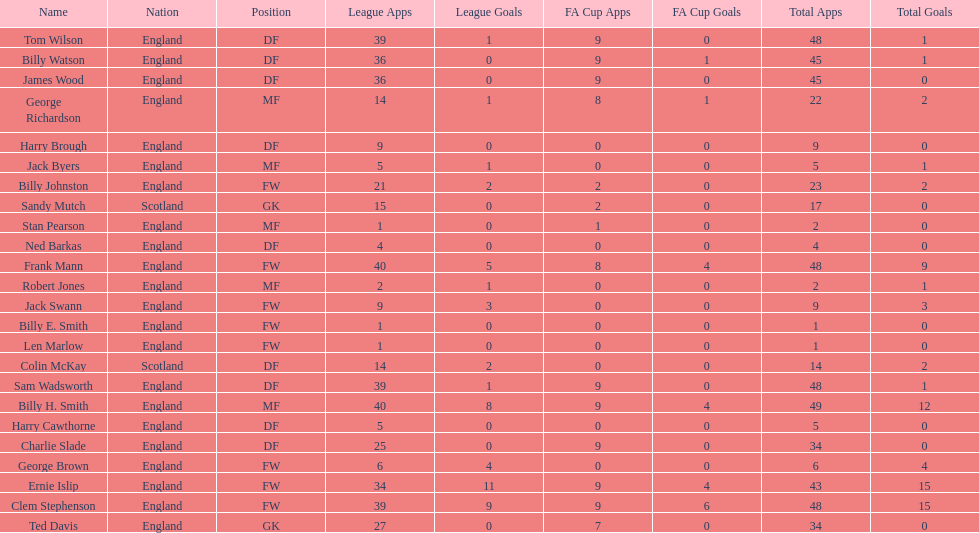Which position is listed the least amount of times on this chart? GK. 